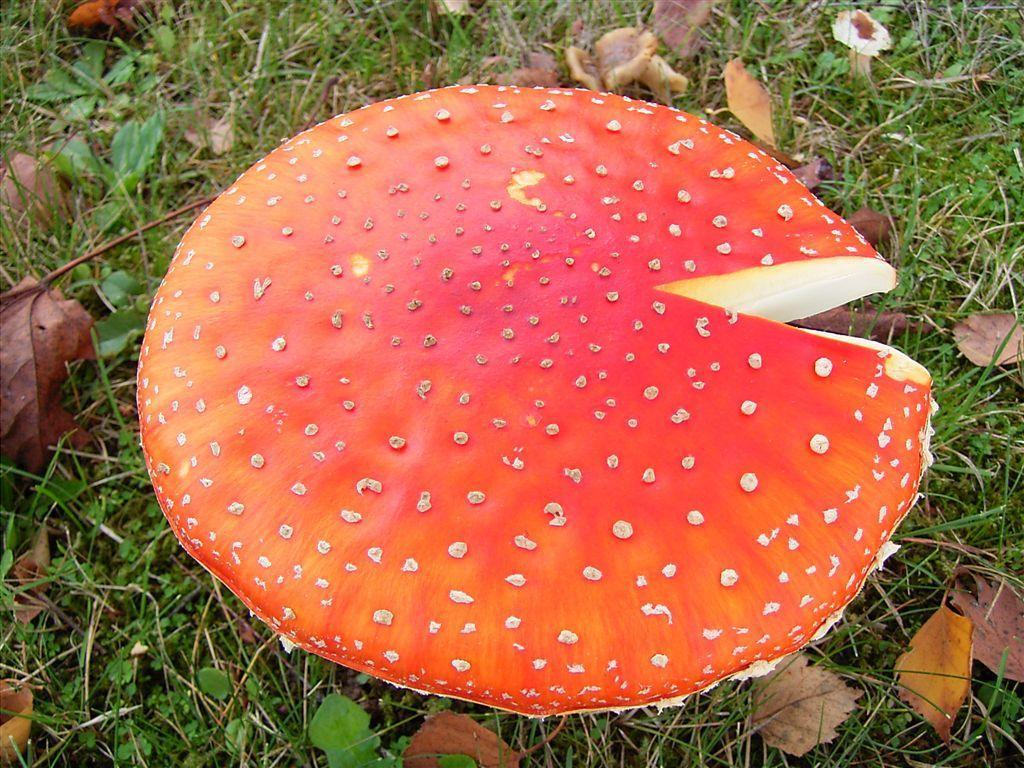In one or two sentences, can you explain what this image depicts? In the picture we can see a grass surface with plant saplings and dried leaves on it and a mushroom which is dark orange and some yellow in color with some spots on it. 